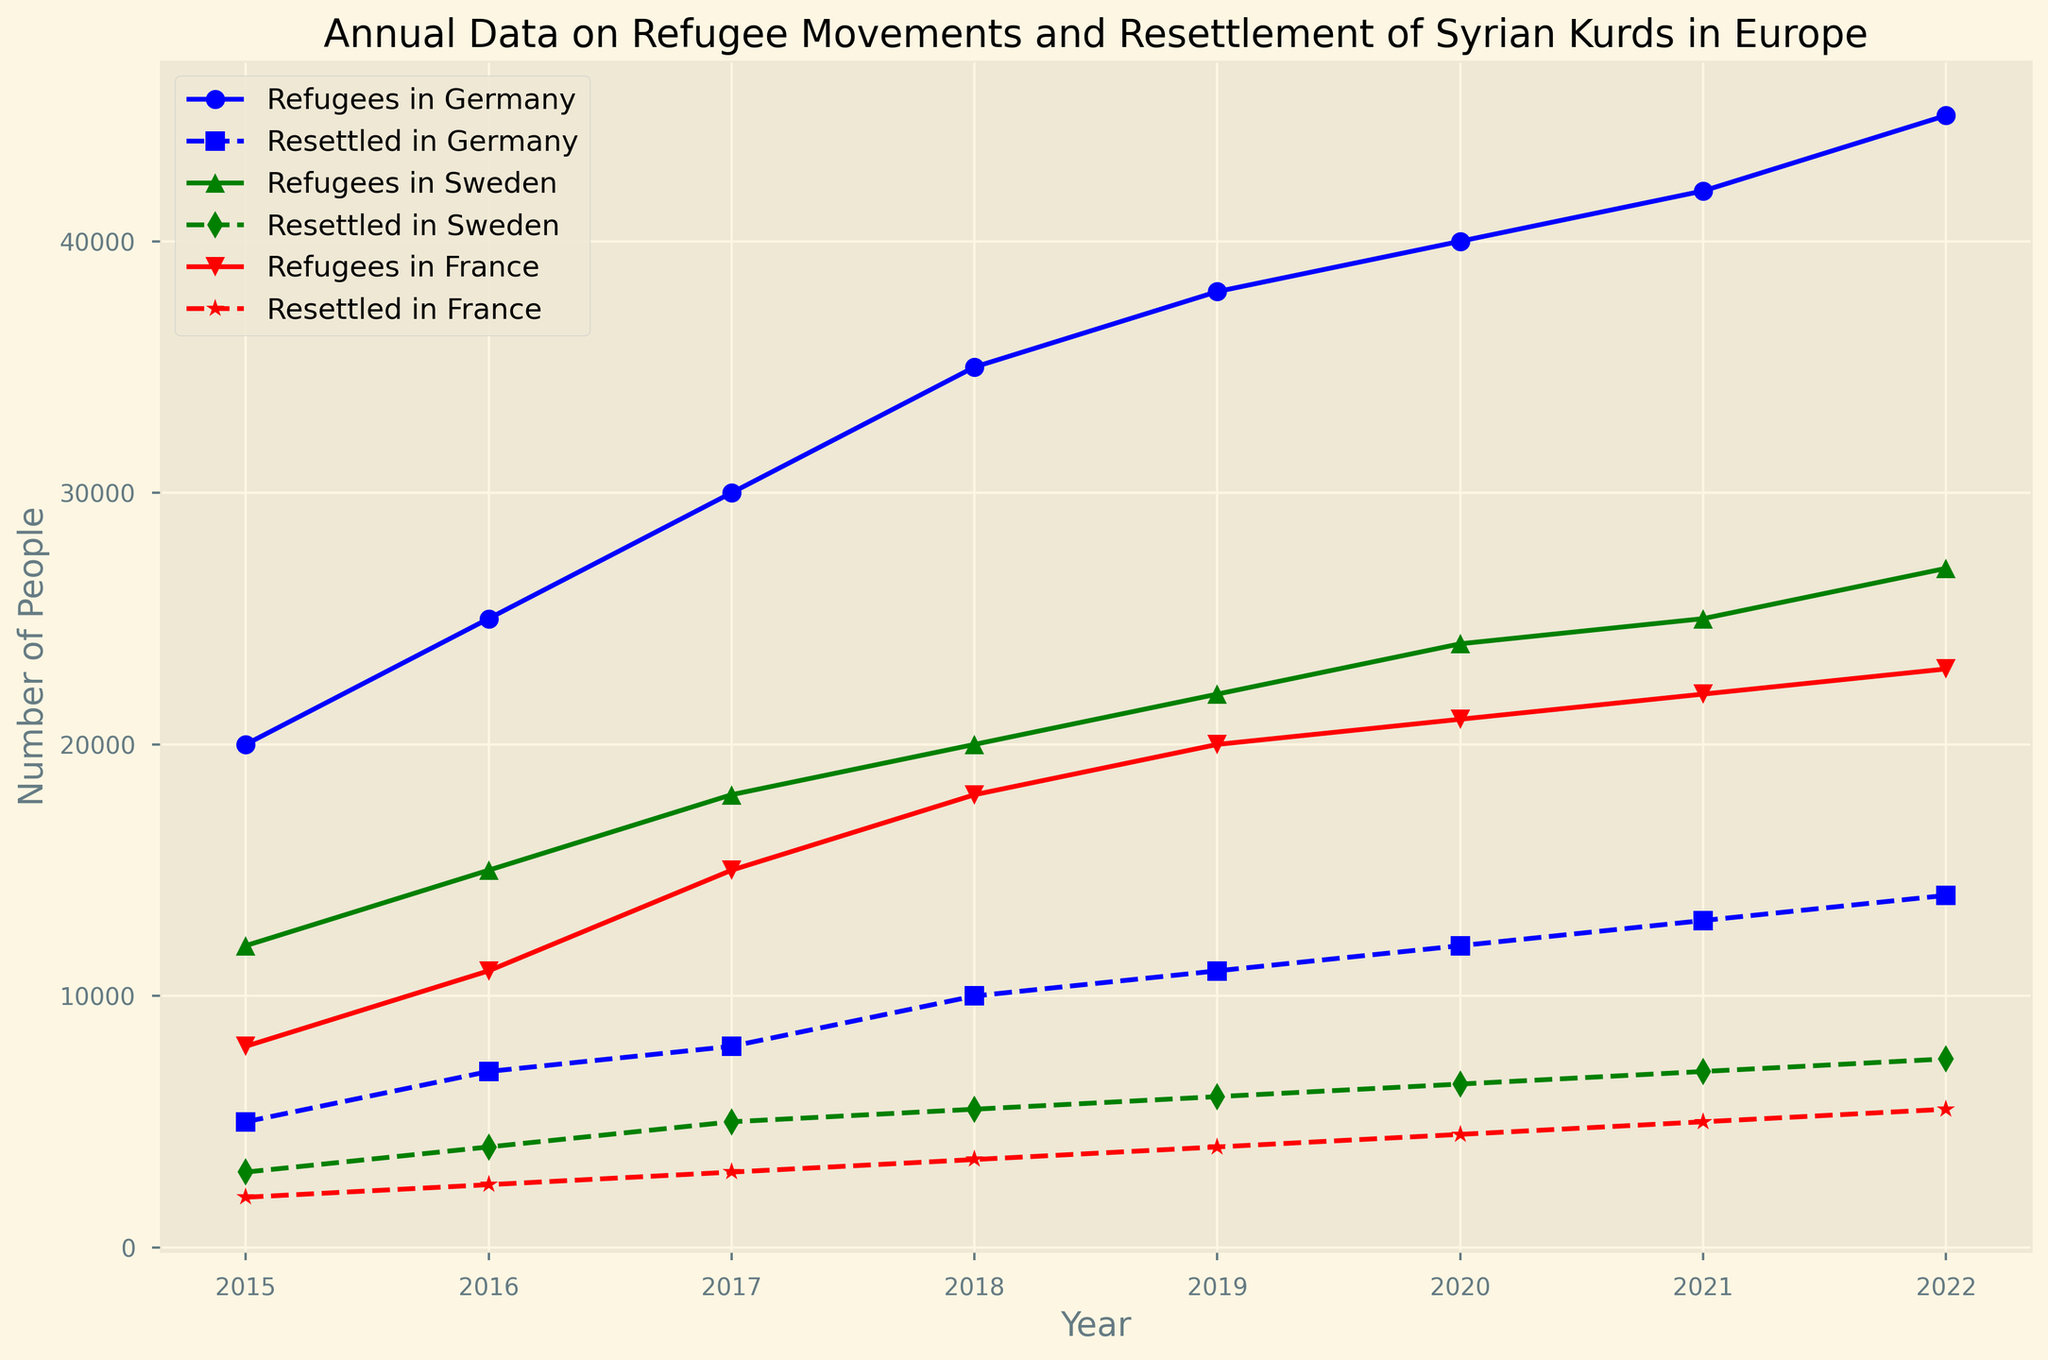What's the trend of the number of refugees in Germany from 2015 to 2022? To determine the trend, look at the line representing "Refugees in Germany" from 2015 to 2022. The number consistently increases year by year, indicating a positive trend.
Answer: Increasing Which country had the highest number of resettled Syrian Kurdish refugees in 2019? Compare the lines representing the "Resettled" values for Germany, Sweden, and France in 2019. The highest peak on the plot signifies the highest number, which is for Germany.
Answer: Germany How did the number of refugees in France change from 2017 to 2022? Observe the "Refugees in France" line from 2017 to 2022. The line consistently moves upward, indicating an increase in the number of refugees over these years.
Answer: Increased In which year did Sweden resettle more refugees than France? Look at the "Resettled in Sweden" and "Resettled in France" lines to identify the years where the former is higher than the latter. It happens in 2015 and 2016.
Answer: 2015 and 2016 What's the total number of resettled refugees in Germany over the years reported in the figure? Sum the "Resettled in Germany" values from 2015 to 2022: 5000 + 7000 + 8000 + 10000 + 11000 + 12000 + 13000 + 14000.
Answer: 80000 Which country had the most refugees in 2018? Compare the values of "Refugees" for Germany, Sweden, and France in 2018. The highest value among the three signifies the country with the most refugees, which is Germany.
Answer: Germany How much did the number of resettled refugees in Sweden increase from 2015 to 2022? Subtract the number of "Resettled in Sweden" in 2015 from that in 2022: 7500 - 3000.
Answer: 4500 Compare the number of refugees in France to those in Sweden in 2020. Which country had more? Compare the "Refugees in France" and "Refugees in Sweden" lines in 2020. The higher value determines the country with more refugees, which is France.
Answer: France Is there any year where the number of resettled refugees in Germany was equal to the number of refugees in Sweden? Observe the intersection points of "Resettled in Germany" and "Refugees in Sweden" lines. There is no year where the values match.
Answer: No 